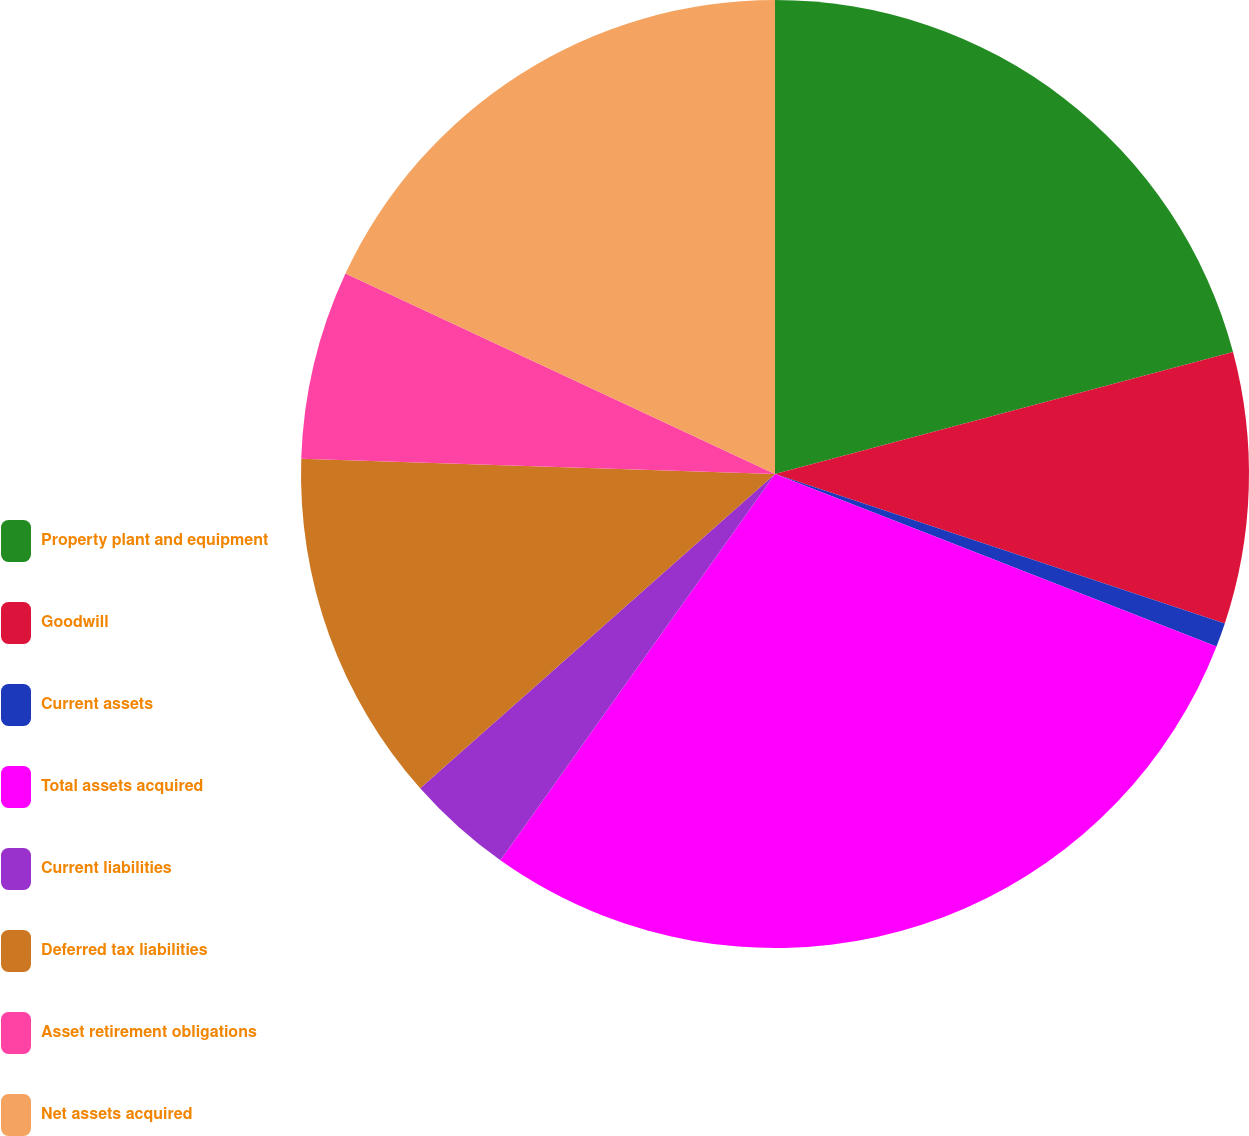<chart> <loc_0><loc_0><loc_500><loc_500><pie_chart><fcel>Property plant and equipment<fcel>Goodwill<fcel>Current assets<fcel>Total assets acquired<fcel>Current liabilities<fcel>Deferred tax liabilities<fcel>Asset retirement obligations<fcel>Net assets acquired<nl><fcel>20.86%<fcel>9.25%<fcel>0.82%<fcel>28.91%<fcel>3.63%<fcel>12.05%<fcel>6.44%<fcel>18.05%<nl></chart> 